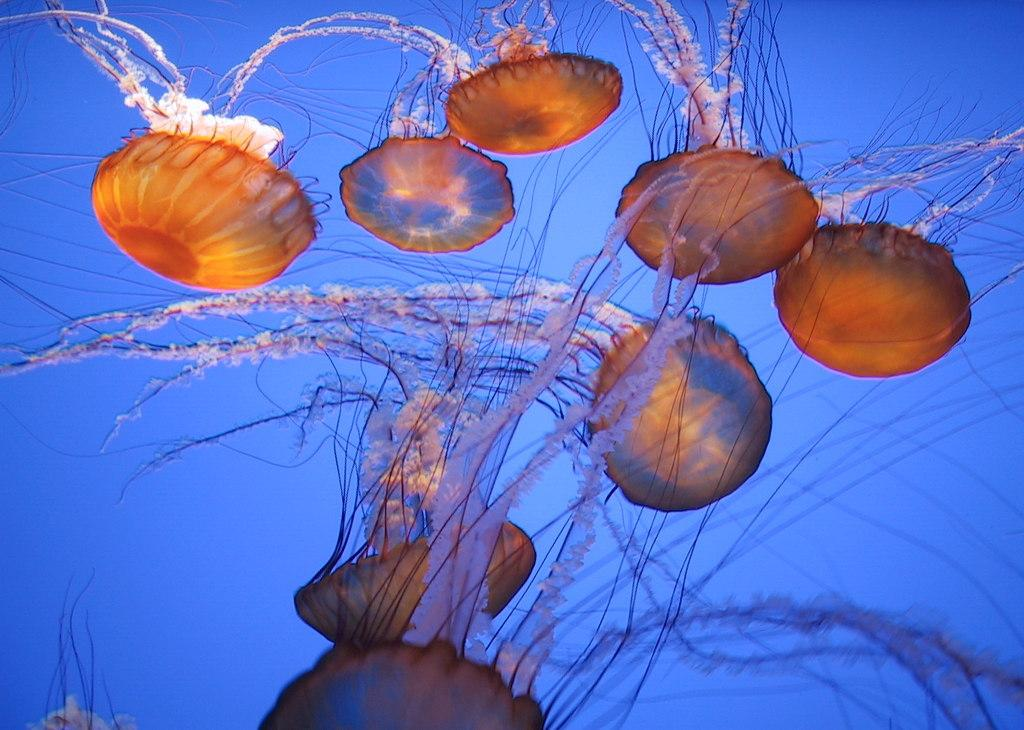What type of animals are in the image? There are jellyfishes in the image. Where are the jellyfishes located? The jellyfishes are in the water. What type of dish is the cook preparing in the image? There is no cook or dish preparation present in the image; it features jellyfishes in the water. What type of cave can be seen in the image? There is no cave present in the image; it features jellyfishes in the water. 